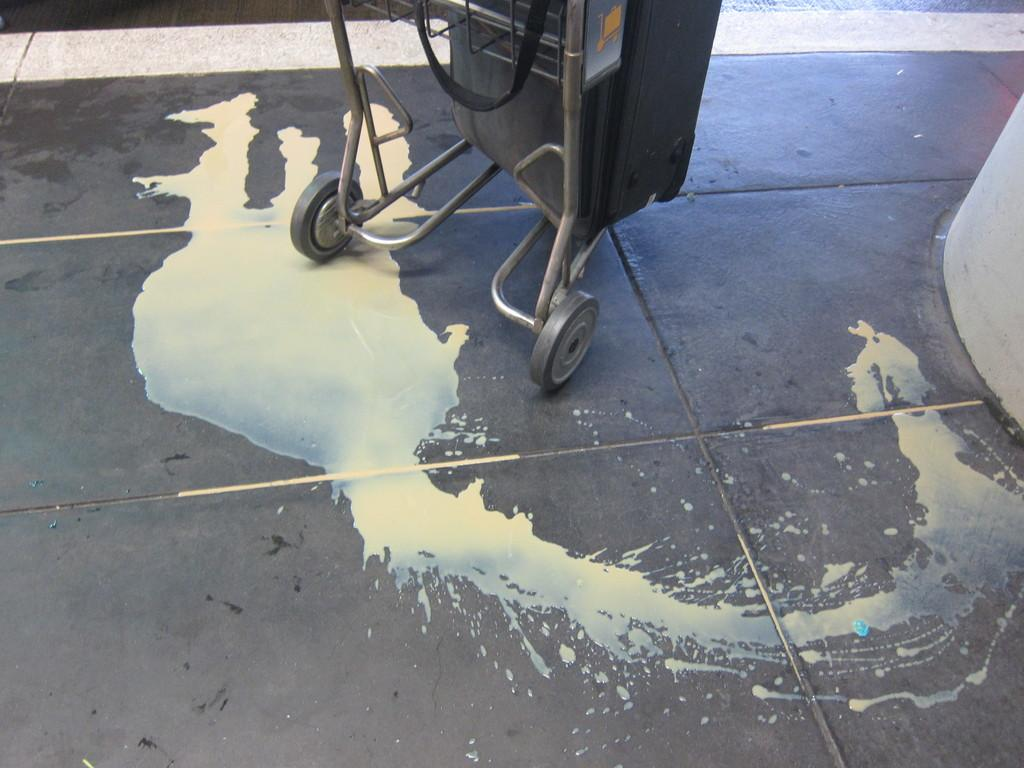What is at the bottom of the image? There is a floor visible at the bottom of the image. What is on the floor in the image? There is some liquid on the floor. What can be seen in the middle of the image? There is a stroller-like vehicle in the middle of the image. What is on the right side of the image? There appears to be a pillar on the right side of the image. What type of fiction is being read by the pipe in the image? There is no pipe or fiction present in the image. How many halls are visible in the image? There are no halls visible in the image. 